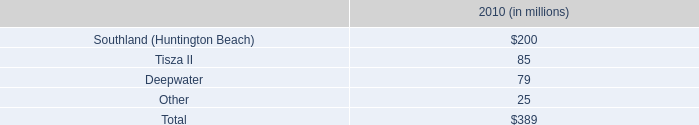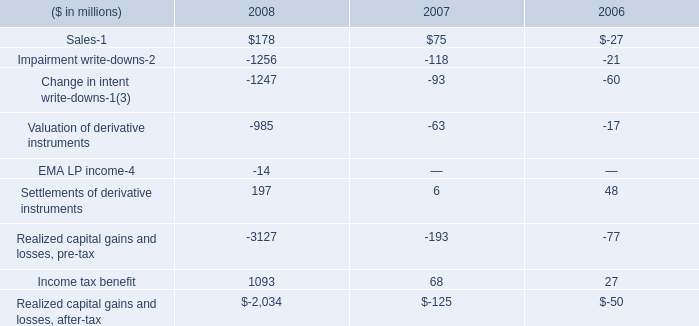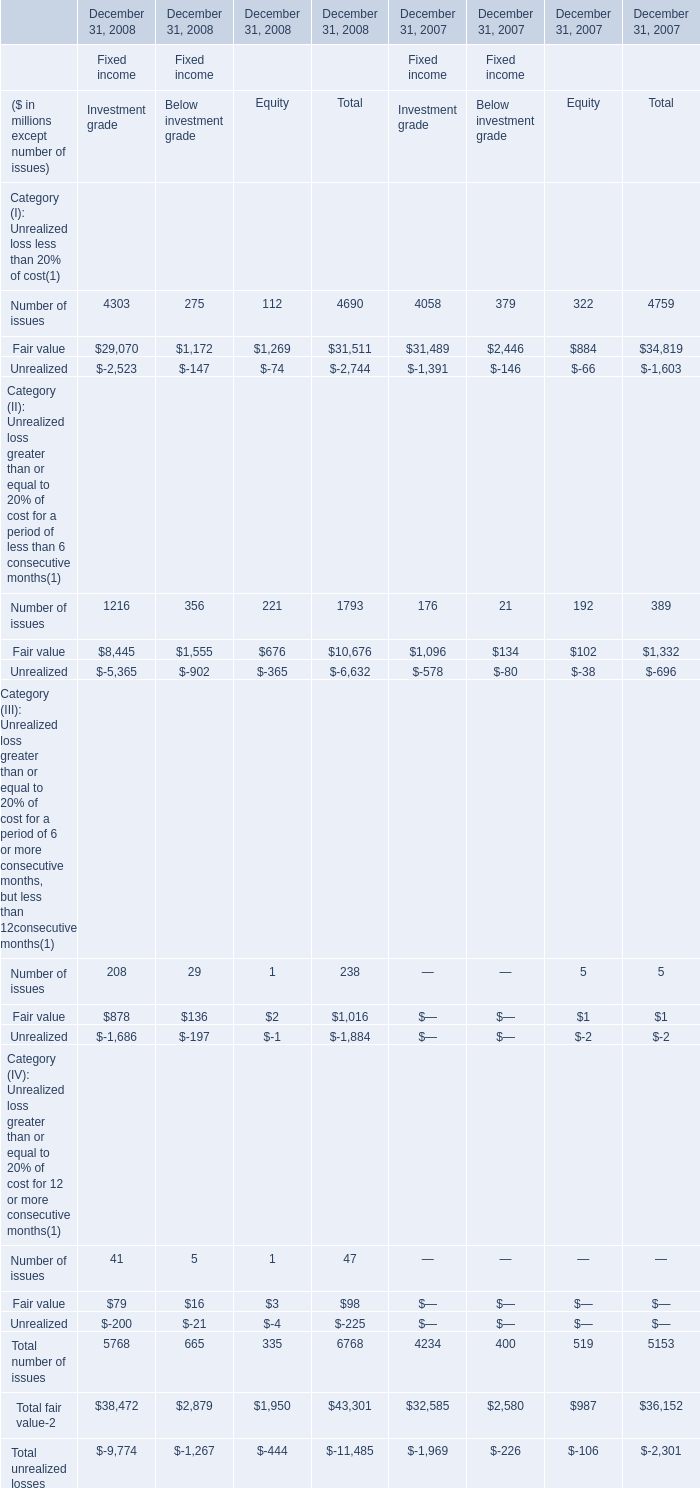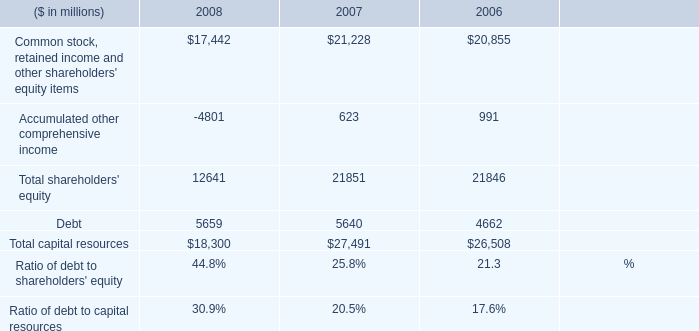In which year is Number of issues for Investment grade positive? 
Answer: December 31, 2008 December 31, 2007. 